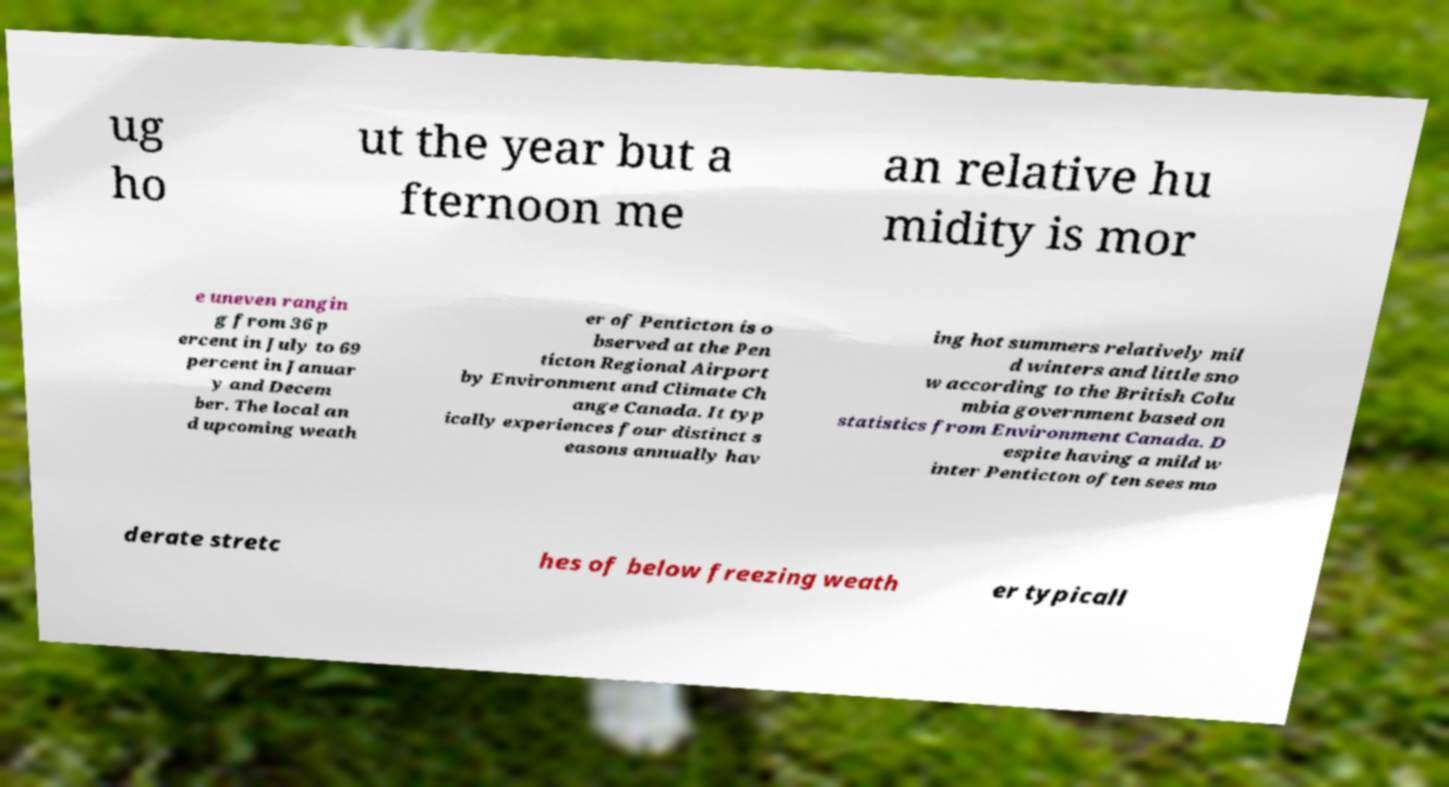For documentation purposes, I need the text within this image transcribed. Could you provide that? ug ho ut the year but a fternoon me an relative hu midity is mor e uneven rangin g from 36 p ercent in July to 69 percent in Januar y and Decem ber. The local an d upcoming weath er of Penticton is o bserved at the Pen ticton Regional Airport by Environment and Climate Ch ange Canada. It typ ically experiences four distinct s easons annually hav ing hot summers relatively mil d winters and little sno w according to the British Colu mbia government based on statistics from Environment Canada. D espite having a mild w inter Penticton often sees mo derate stretc hes of below freezing weath er typicall 